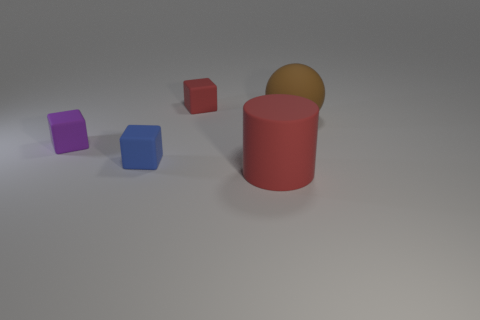There is a small object that is the same color as the matte cylinder; what is it made of?
Your response must be concise. Rubber. How many objects are brown matte objects or yellow metal cubes?
Provide a succinct answer. 1. What is the shape of the large rubber object behind the big red matte thing?
Keep it short and to the point. Sphere. The cylinder that is the same material as the tiny purple cube is what color?
Give a very brief answer. Red. There is a tiny purple object that is the same shape as the blue thing; what is it made of?
Give a very brief answer. Rubber. What is the shape of the purple object?
Your response must be concise. Cube. There is a thing that is both in front of the brown rubber ball and to the right of the blue matte object; what is its material?
Ensure brevity in your answer.  Rubber. What shape is the small purple thing that is made of the same material as the blue cube?
Ensure brevity in your answer.  Cube. There is a purple object that is made of the same material as the big brown object; what is its size?
Your answer should be very brief. Small. There is a thing that is both in front of the brown thing and on the right side of the blue cube; what shape is it?
Your answer should be compact. Cylinder. 